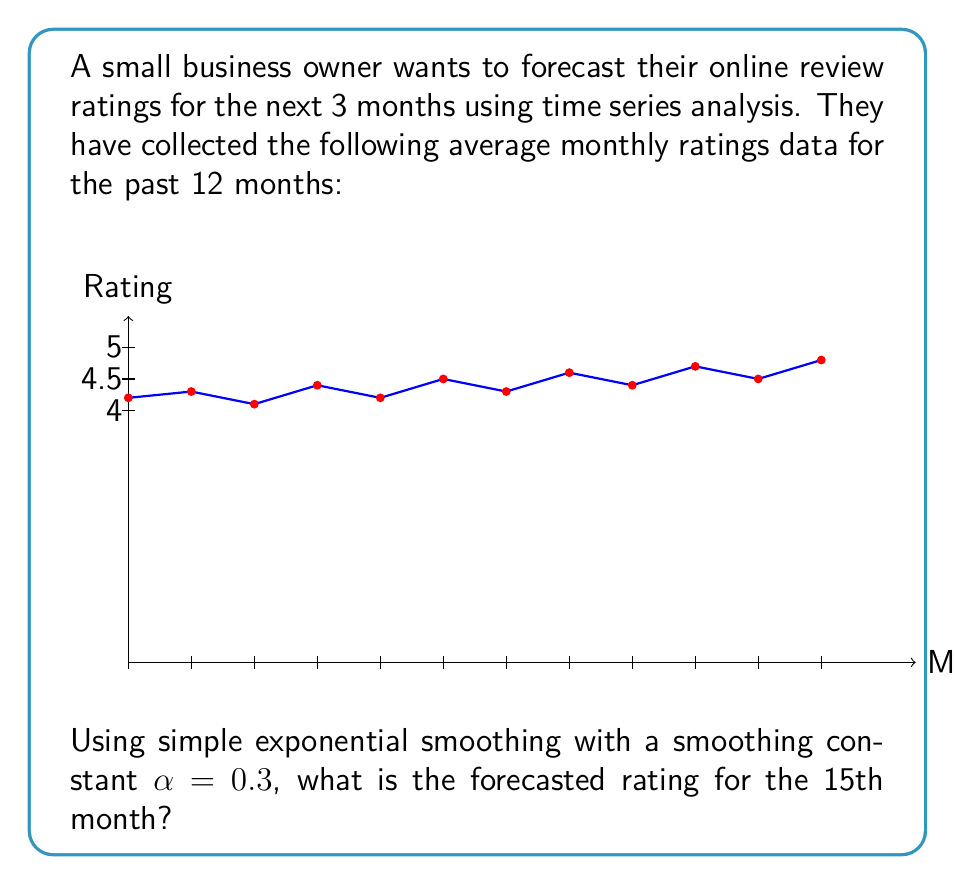Help me with this question. To solve this problem using simple exponential smoothing, we'll follow these steps:

1) The formula for simple exponential smoothing is:
   $$F_{t+1} = \alpha Y_t + (1-\alpha)F_t$$
   where $F_{t+1}$ is the forecast for the next period, $Y_t$ is the actual value at time $t$, and $F_t$ is the forecast for the current period.

2) We're given $\alpha = 0.3$. We'll use the last observed value (4.8) as our initial forecast.

3) For the 13th month forecast:
   $$F_{13} = 0.3(4.8) + 0.7(4.8) = 4.8$$

4) For the 14th month forecast:
   $$F_{14} = 0.3(4.8) + 0.7(4.8) = 4.8$$

5) For the 15th month forecast:
   $$F_{15} = 0.3(4.8) + 0.7(4.8) = 4.8$$

The forecast remains constant because we don't have new observed values after the 12th month, and we're using the last observed value as our initial forecast.
Answer: 4.8 